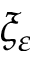<formula> <loc_0><loc_0><loc_500><loc_500>\xi _ { \varepsilon }</formula> 